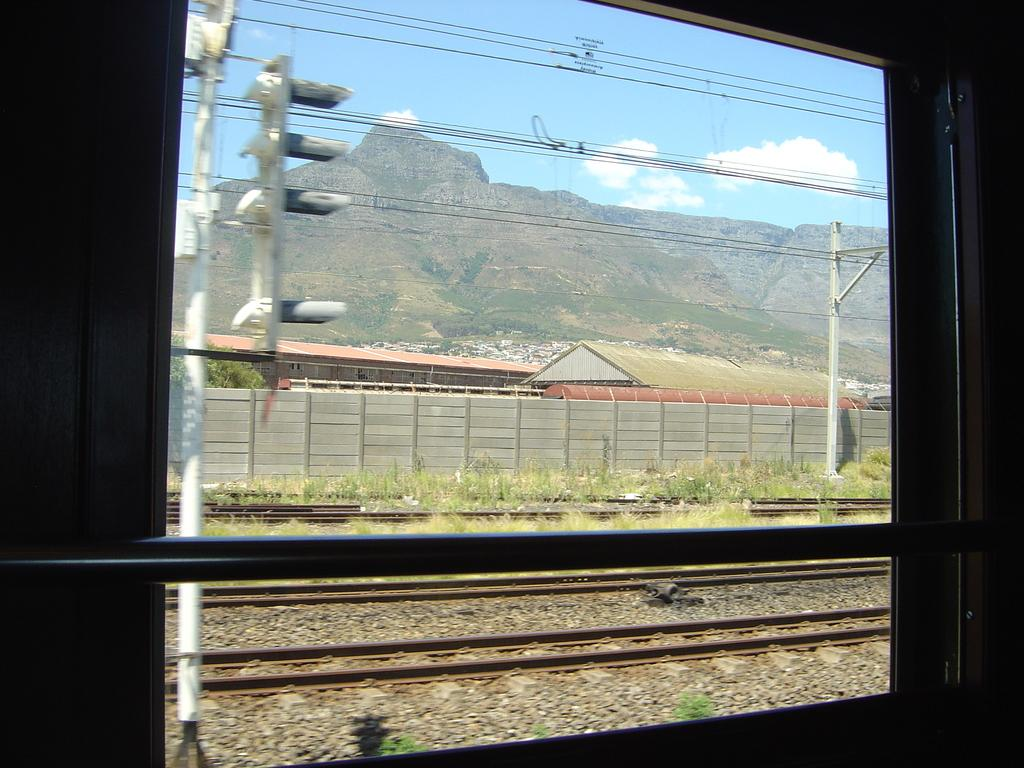What structure can be seen in the image? There is a signal light pole in the image. What type of transportation infrastructure is visible in the image? Railway tracks are visible in the image. What natural features can be seen in the image? There are hills in the image. What is the condition of the sky in the image? Clouds are present in the sky. What type of construction is visible in the image? There is a shed construction in the image. What type of barrier is present in the image? A wall fence is visible in the image. What type of drawer can be seen in the image? There is no drawer present in the image. What type of thunder can be heard in the image? The image is a still picture, so there is no sound or thunder present. 